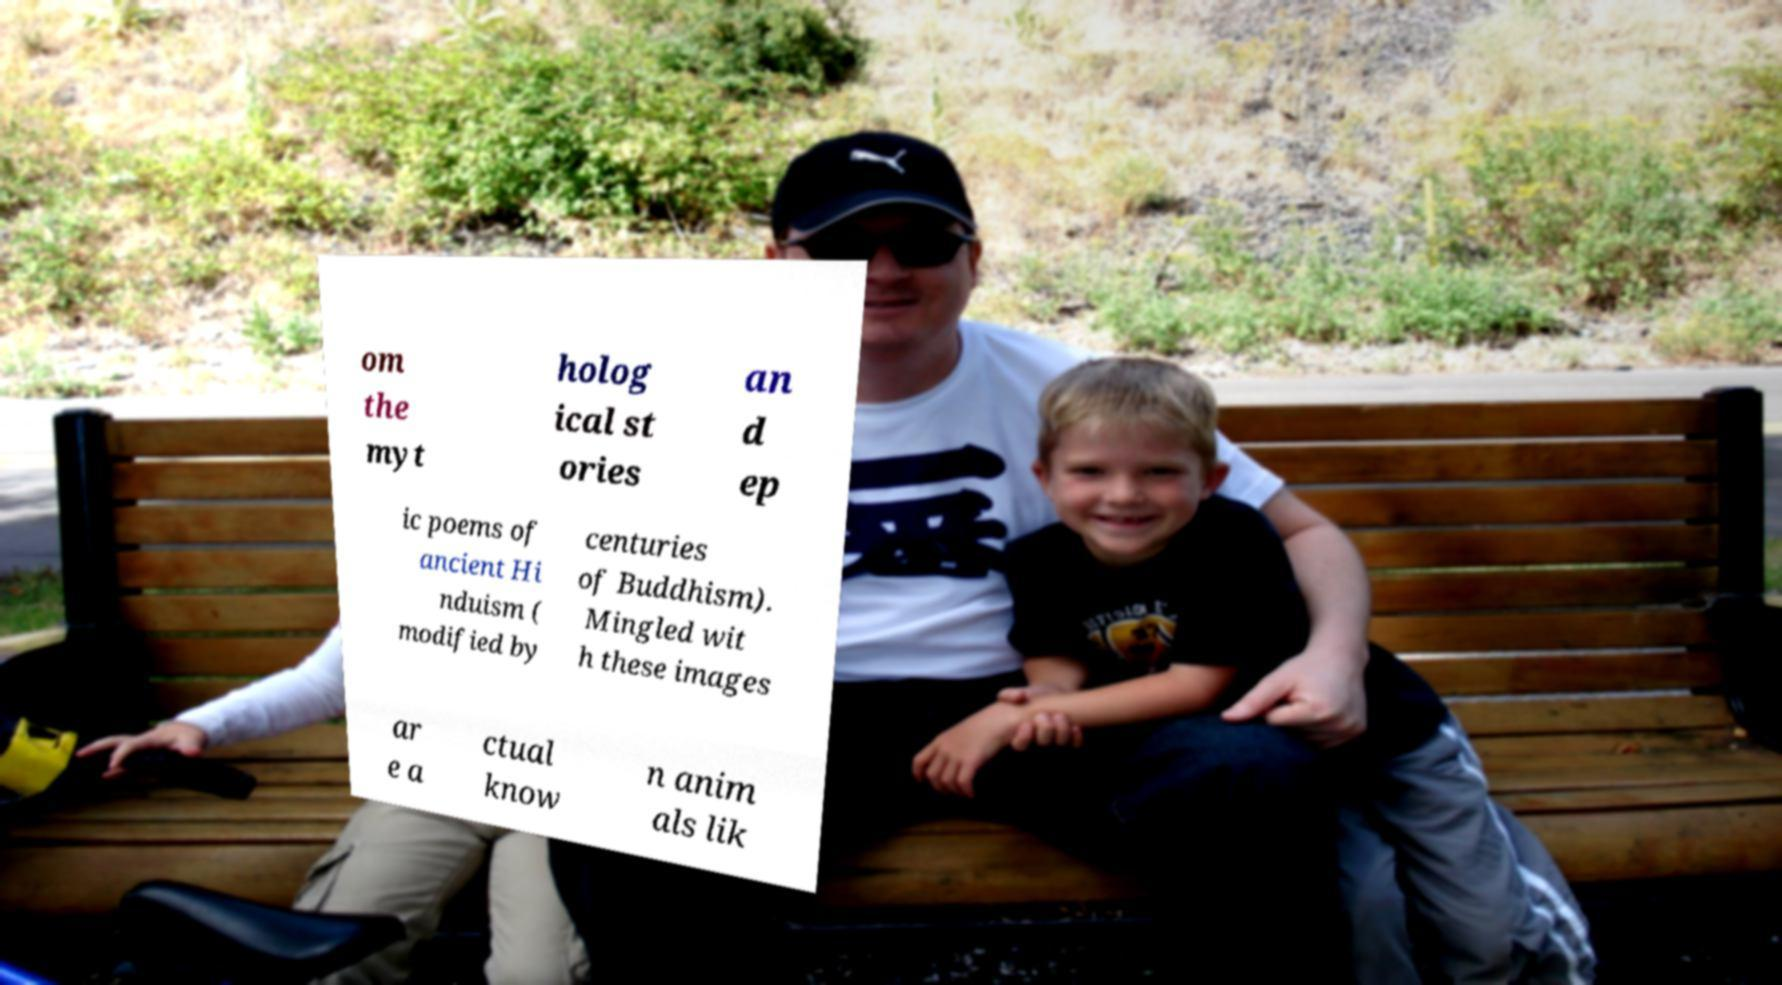For documentation purposes, I need the text within this image transcribed. Could you provide that? om the myt holog ical st ories an d ep ic poems of ancient Hi nduism ( modified by centuries of Buddhism). Mingled wit h these images ar e a ctual know n anim als lik 